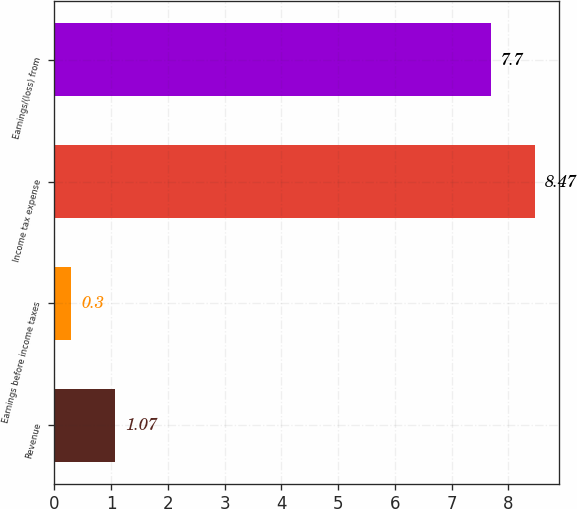<chart> <loc_0><loc_0><loc_500><loc_500><bar_chart><fcel>Revenue<fcel>Earnings before income taxes<fcel>Income tax expense<fcel>Earnings/(loss) from<nl><fcel>1.07<fcel>0.3<fcel>8.47<fcel>7.7<nl></chart> 